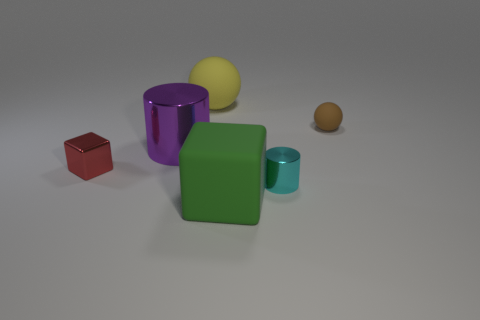Add 4 red matte blocks. How many objects exist? 10 Subtract all cylinders. How many objects are left? 4 Subtract 0 red cylinders. How many objects are left? 6 Subtract all balls. Subtract all green matte things. How many objects are left? 3 Add 2 tiny cylinders. How many tiny cylinders are left? 3 Add 3 metallic cylinders. How many metallic cylinders exist? 5 